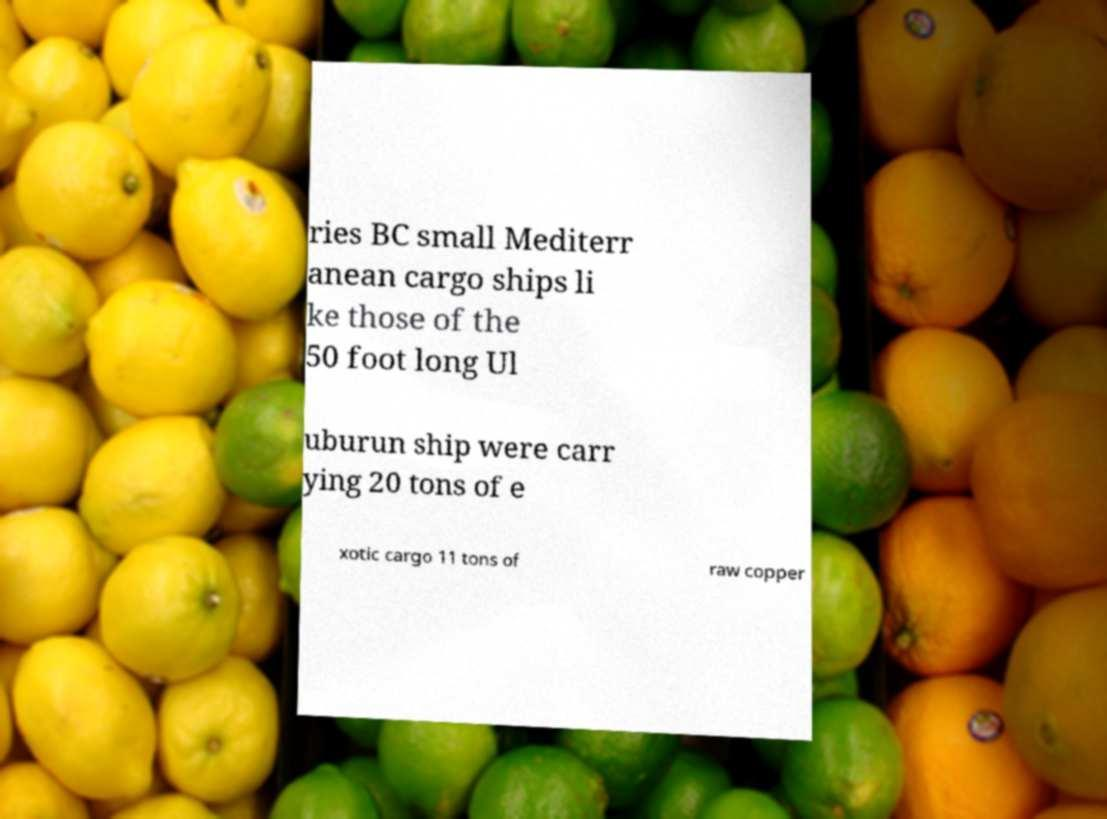I need the written content from this picture converted into text. Can you do that? ries BC small Mediterr anean cargo ships li ke those of the 50 foot long Ul uburun ship were carr ying 20 tons of e xotic cargo 11 tons of raw copper 